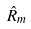<formula> <loc_0><loc_0><loc_500><loc_500>\hat { R } _ { m }</formula> 